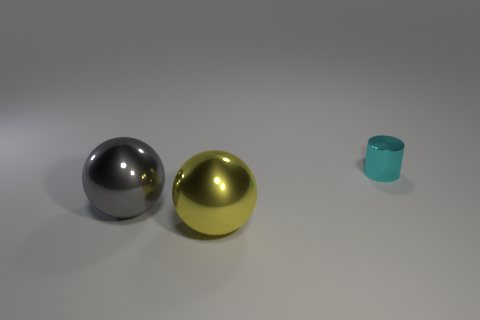There is a thing behind the gray thing; what is its size?
Your answer should be very brief. Small. Is there anything else that is the same shape as the yellow object?
Your response must be concise. Yes. Are there an equal number of yellow metal balls on the left side of the large gray metallic thing and blue things?
Your answer should be compact. Yes. Are there any big spheres in front of the large gray thing?
Give a very brief answer. Yes. There is a gray metal thing; is it the same shape as the large metal object to the right of the gray metallic thing?
Provide a succinct answer. Yes. The cylinder that is made of the same material as the big yellow thing is what color?
Offer a very short reply. Cyan. What color is the metallic cylinder?
Make the answer very short. Cyan. Do the gray thing and the large object that is in front of the gray sphere have the same material?
Give a very brief answer. Yes. What number of objects are both right of the yellow metal ball and on the left side of the tiny cyan metal cylinder?
Your response must be concise. 0. The other object that is the same size as the yellow metal thing is what shape?
Make the answer very short. Sphere. 